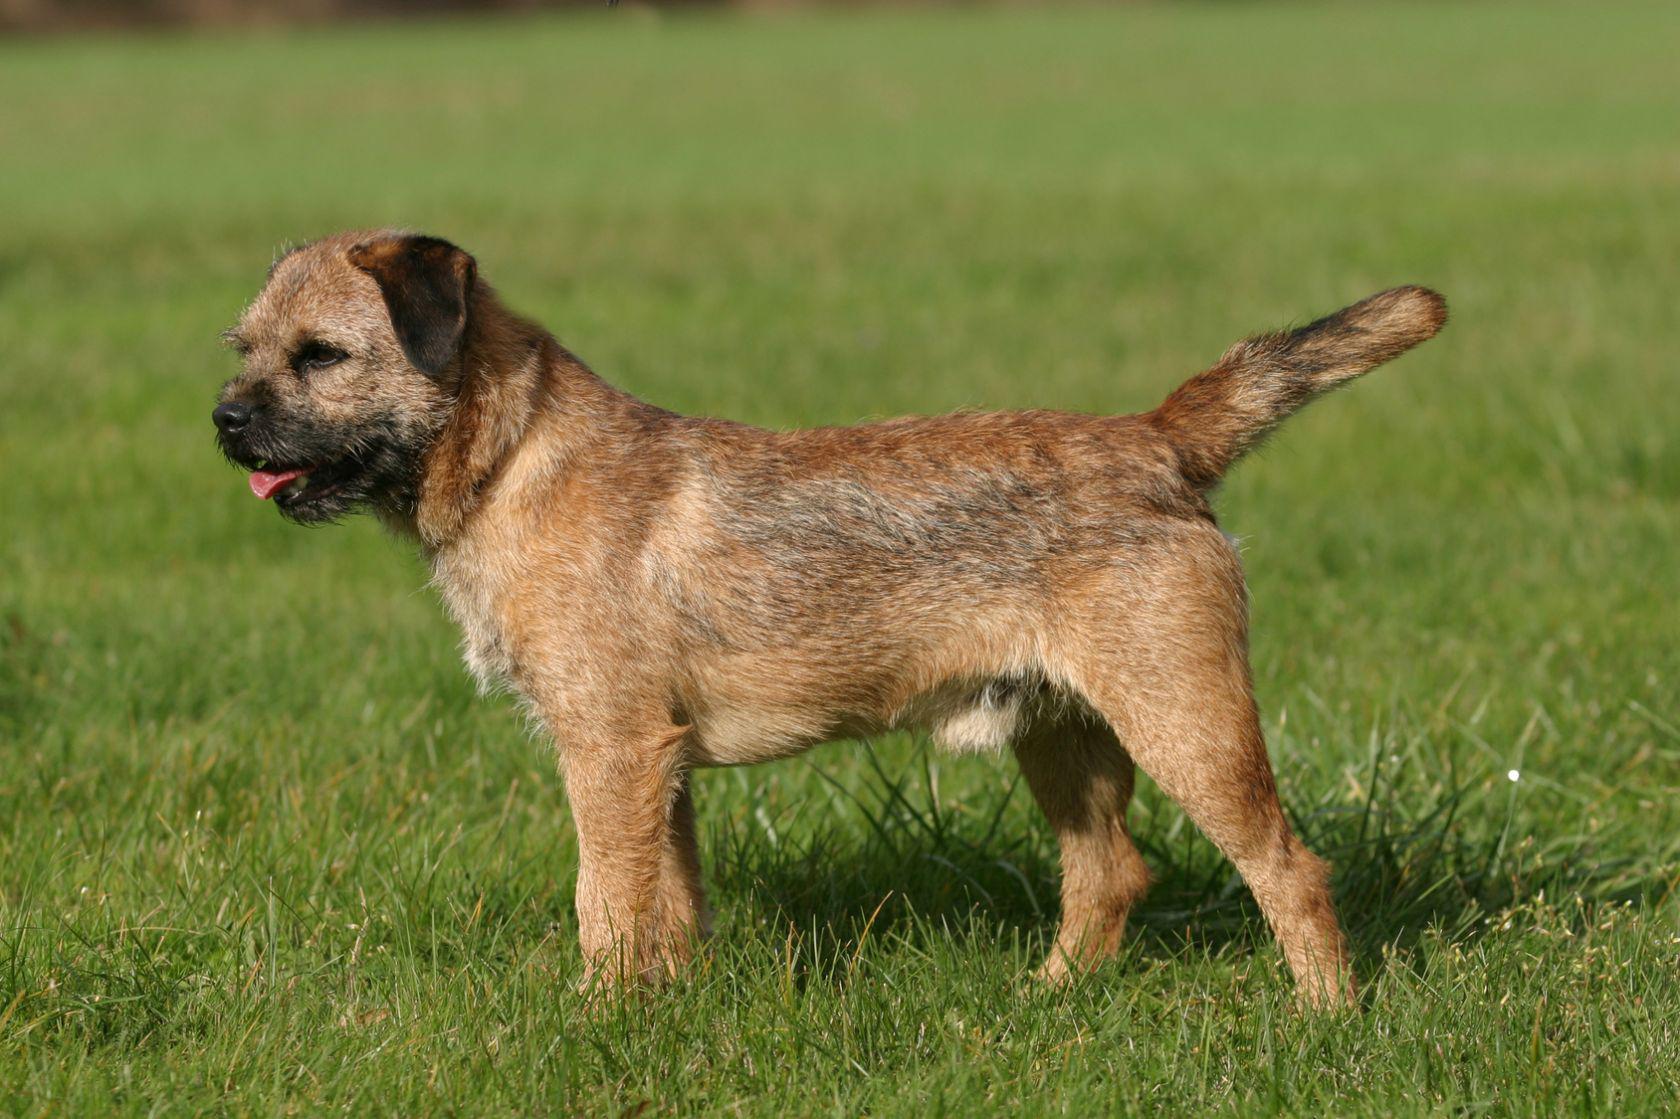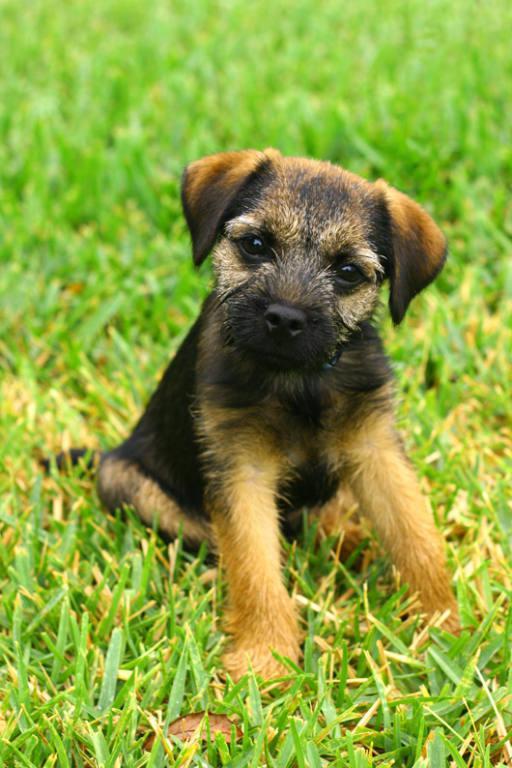The first image is the image on the left, the second image is the image on the right. Assess this claim about the two images: "Right image shows puppy standing on grass with one paw raised.". Correct or not? Answer yes or no. No. The first image is the image on the left, the second image is the image on the right. Considering the images on both sides, is "Two small dogs with floppy ears are in green grassy areas." valid? Answer yes or no. Yes. 